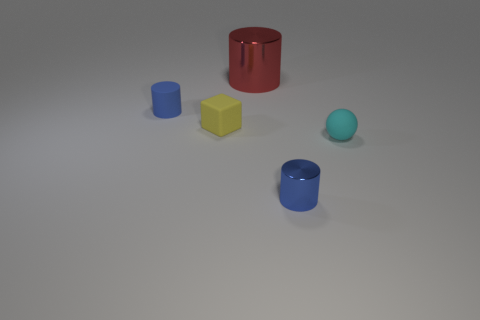Is there any other thing that has the same size as the red cylinder?
Offer a very short reply. No. What number of large metal objects are there?
Offer a very short reply. 1. What number of tiny spheres have the same color as the small metal cylinder?
Your answer should be very brief. 0. There is a small rubber object that is on the right side of the big metal thing; is it the same shape as the shiny thing right of the big red metallic cylinder?
Offer a terse response. No. What color is the metal cylinder in front of the blue cylinder behind the blue object that is on the right side of the yellow matte object?
Provide a succinct answer. Blue. What color is the metal object behind the tiny blue rubber cylinder?
Ensure brevity in your answer.  Red. What color is the ball that is the same size as the yellow matte thing?
Give a very brief answer. Cyan. Is the matte cylinder the same size as the matte sphere?
Provide a short and direct response. Yes. There is a small blue shiny cylinder; how many matte things are on the right side of it?
Offer a very short reply. 1. What number of things are objects behind the small cube or yellow blocks?
Your response must be concise. 3. 